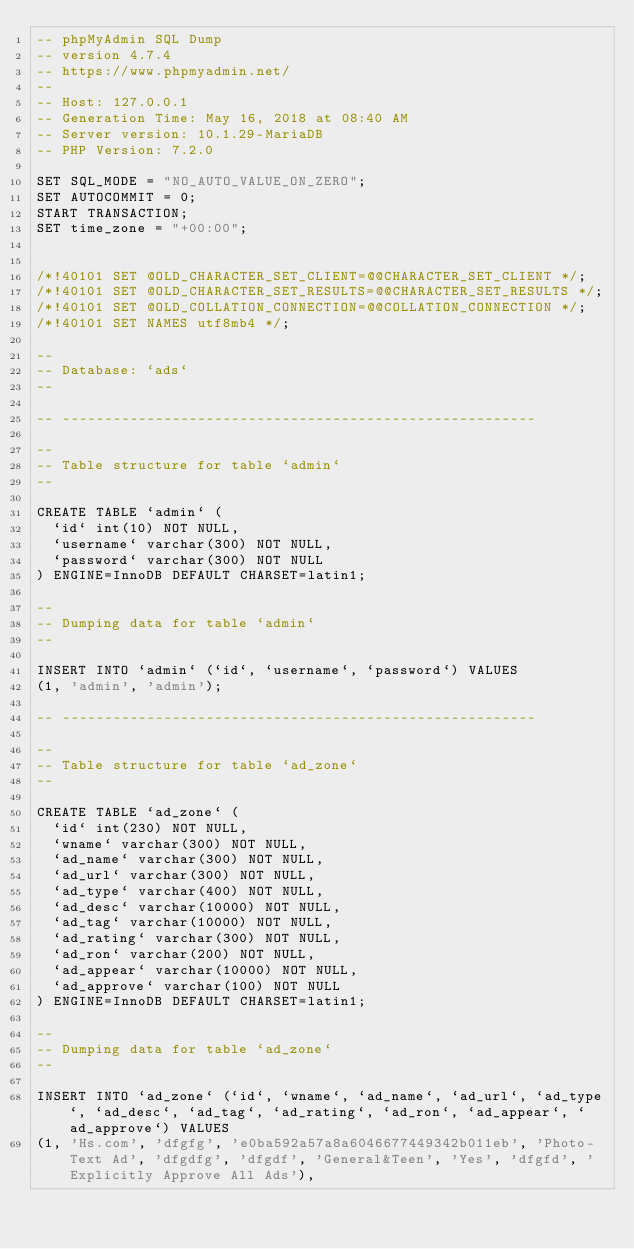Convert code to text. <code><loc_0><loc_0><loc_500><loc_500><_SQL_>-- phpMyAdmin SQL Dump
-- version 4.7.4
-- https://www.phpmyadmin.net/
--
-- Host: 127.0.0.1
-- Generation Time: May 16, 2018 at 08:40 AM
-- Server version: 10.1.29-MariaDB
-- PHP Version: 7.2.0

SET SQL_MODE = "NO_AUTO_VALUE_ON_ZERO";
SET AUTOCOMMIT = 0;
START TRANSACTION;
SET time_zone = "+00:00";


/*!40101 SET @OLD_CHARACTER_SET_CLIENT=@@CHARACTER_SET_CLIENT */;
/*!40101 SET @OLD_CHARACTER_SET_RESULTS=@@CHARACTER_SET_RESULTS */;
/*!40101 SET @OLD_COLLATION_CONNECTION=@@COLLATION_CONNECTION */;
/*!40101 SET NAMES utf8mb4 */;

--
-- Database: `ads`
--

-- --------------------------------------------------------

--
-- Table structure for table `admin`
--

CREATE TABLE `admin` (
  `id` int(10) NOT NULL,
  `username` varchar(300) NOT NULL,
  `password` varchar(300) NOT NULL
) ENGINE=InnoDB DEFAULT CHARSET=latin1;

--
-- Dumping data for table `admin`
--

INSERT INTO `admin` (`id`, `username`, `password`) VALUES
(1, 'admin', 'admin');

-- --------------------------------------------------------

--
-- Table structure for table `ad_zone`
--

CREATE TABLE `ad_zone` (
  `id` int(230) NOT NULL,
  `wname` varchar(300) NOT NULL,
  `ad_name` varchar(300) NOT NULL,
  `ad_url` varchar(300) NOT NULL,
  `ad_type` varchar(400) NOT NULL,
  `ad_desc` varchar(10000) NOT NULL,
  `ad_tag` varchar(10000) NOT NULL,
  `ad_rating` varchar(300) NOT NULL,
  `ad_ron` varchar(200) NOT NULL,
  `ad_appear` varchar(10000) NOT NULL,
  `ad_approve` varchar(100) NOT NULL
) ENGINE=InnoDB DEFAULT CHARSET=latin1;

--
-- Dumping data for table `ad_zone`
--

INSERT INTO `ad_zone` (`id`, `wname`, `ad_name`, `ad_url`, `ad_type`, `ad_desc`, `ad_tag`, `ad_rating`, `ad_ron`, `ad_appear`, `ad_approve`) VALUES
(1, 'Hs.com', 'dfgfg', 'e0ba592a57a8a6046677449342b011eb', 'Photo-Text Ad', 'dfgdfg', 'dfgdf', 'General&Teen', 'Yes', 'dfgfd', 'Explicitly Approve All Ads'),</code> 